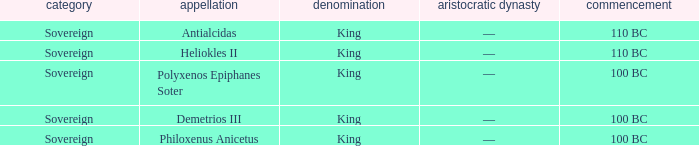Write the full table. {'header': ['category', 'appellation', 'denomination', 'aristocratic dynasty', 'commencement'], 'rows': [['Sovereign', 'Antialcidas', 'King', '—', '110 BC'], ['Sovereign', 'Heliokles II', 'King', '—', '110 BC'], ['Sovereign', 'Polyxenos Epiphanes Soter', 'King', '—', '100 BC'], ['Sovereign', 'Demetrios III', 'King', '—', '100 BC'], ['Sovereign', 'Philoxenus Anicetus', 'King', '—', '100 BC']]} Which royal house corresponds to Polyxenos Epiphanes Soter? —. 